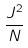<formula> <loc_0><loc_0><loc_500><loc_500>\frac { J ^ { 2 } } { N }</formula> 